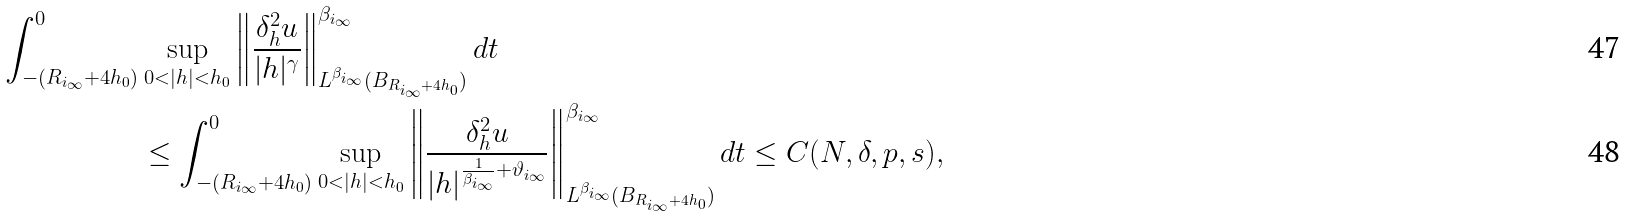<formula> <loc_0><loc_0><loc_500><loc_500>\int _ { - ( R _ { i _ { \infty } } + 4 h _ { 0 } ) } ^ { 0 } & \sup _ { 0 < | h | < { h _ { 0 } } } \left \| \frac { \delta ^ { 2 } _ { h } u } { | h | ^ { \gamma } } \right \| _ { L ^ { \beta _ { i _ { \infty } } } ( B _ { R _ { i _ { \infty } } + 4 h _ { 0 } } ) } ^ { \beta _ { i _ { \infty } } } d t \\ & \leq \int _ { - ( R _ { i _ { \infty } } + 4 h _ { 0 } ) } ^ { 0 } \sup _ { 0 < | h | < { h _ { 0 } } } \left \| \frac { \delta ^ { 2 } _ { h } u } { | h | ^ { \frac { 1 } { \beta _ { i _ { \infty } } } + \vartheta _ { i _ { \infty } } } } \right \| _ { L ^ { \beta _ { i _ { \infty } } } ( B _ { R _ { i _ { \infty } } + 4 h _ { 0 } } ) } ^ { \beta _ { i _ { \infty } } } d t \leq C ( N , \delta , p , s ) ,</formula> 